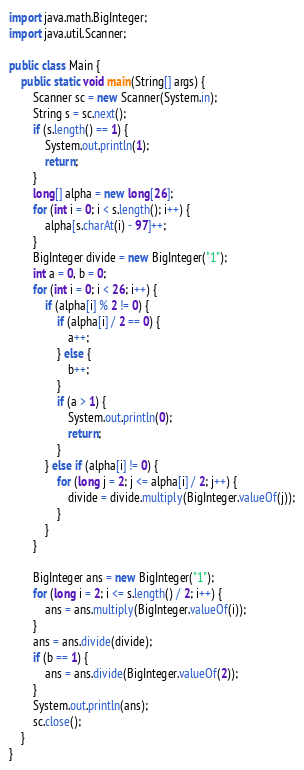<code> <loc_0><loc_0><loc_500><loc_500><_Java_>import java.math.BigInteger;
import java.util.Scanner;

public class Main {
	public static void main(String[] args) {
		Scanner sc = new Scanner(System.in);
		String s = sc.next();
		if (s.length() == 1) {
			System.out.println(1);
			return;
		}
		long[] alpha = new long[26];
		for (int i = 0; i < s.length(); i++) {
			alpha[s.charAt(i) - 97]++;
		}
		BigInteger divide = new BigInteger("1");
		int a = 0, b = 0;
		for (int i = 0; i < 26; i++) {
			if (alpha[i] % 2 != 0) {
				if (alpha[i] / 2 == 0) {
					a++;
				} else {
					b++;
				}
				if (a > 1) {
					System.out.println(0);
					return;
				}
			} else if (alpha[i] != 0) {
				for (long j = 2; j <= alpha[i] / 2; j++) {
					divide = divide.multiply(BigInteger.valueOf(j));
				}
			}
		}

		BigInteger ans = new BigInteger("1");
		for (long i = 2; i <= s.length() / 2; i++) {
			ans = ans.multiply(BigInteger.valueOf(i));
		}
		ans = ans.divide(divide);
		if (b == 1) {
			ans = ans.divide(BigInteger.valueOf(2));
		}
		System.out.println(ans);
		sc.close();
	}
}</code> 